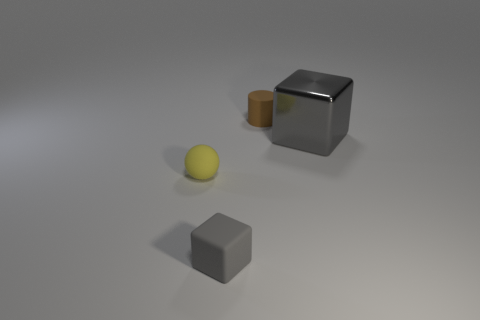Add 2 small cyan things. How many objects exist? 6 Subtract all cylinders. How many objects are left? 3 Subtract 1 brown cylinders. How many objects are left? 3 Subtract 2 cubes. How many cubes are left? 0 Subtract all green balls. Subtract all gray blocks. How many balls are left? 1 Subtract all purple cylinders. How many cyan balls are left? 0 Subtract all large gray metallic blocks. Subtract all big gray metallic blocks. How many objects are left? 2 Add 2 gray matte blocks. How many gray matte blocks are left? 3 Add 2 tiny gray metal balls. How many tiny gray metal balls exist? 2 